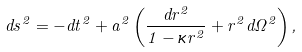Convert formula to latex. <formula><loc_0><loc_0><loc_500><loc_500>d s ^ { 2 } = - d t ^ { 2 } + a ^ { 2 } \left ( \frac { d r ^ { 2 } } { 1 - \kappa r ^ { 2 } } + r ^ { 2 } d \Omega ^ { 2 } \right ) ,</formula> 